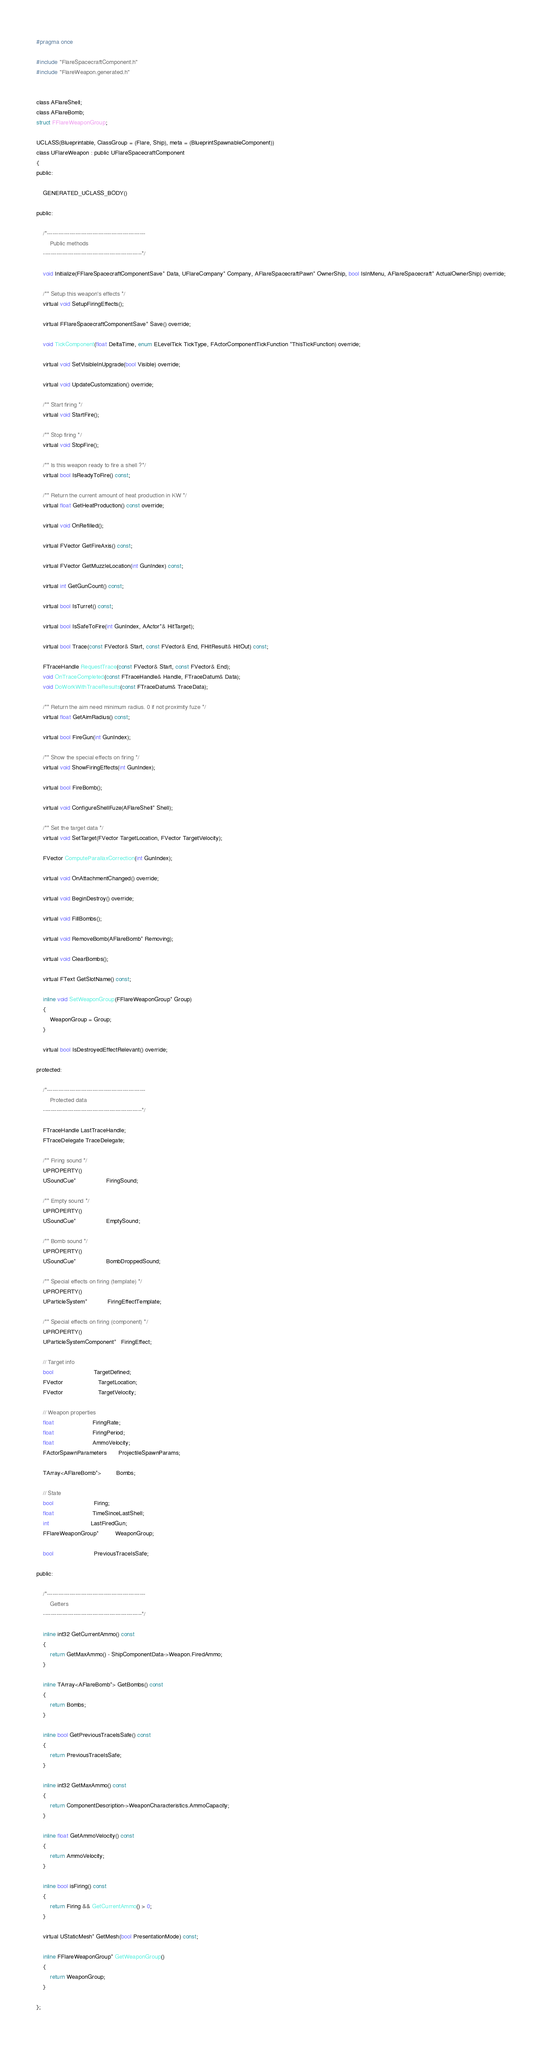Convert code to text. <code><loc_0><loc_0><loc_500><loc_500><_C_>#pragma once

#include "FlareSpacecraftComponent.h"
#include "FlareWeapon.generated.h"


class AFlareShell;
class AFlareBomb;
struct FFlareWeaponGroup;

UCLASS(Blueprintable, ClassGroup = (Flare, Ship), meta = (BlueprintSpawnableComponent))
class UFlareWeapon : public UFlareSpacecraftComponent
{
public:

	GENERATED_UCLASS_BODY()

public:

	/*----------------------------------------------------
		Public methods
	----------------------------------------------------*/

	void Initialize(FFlareSpacecraftComponentSave* Data, UFlareCompany* Company, AFlareSpacecraftPawn* OwnerShip, bool IsInMenu, AFlareSpacecraft* ActualOwnerShip) override;

	/** Setup this weapon's effects */
	virtual void SetupFiringEffects();

	virtual FFlareSpacecraftComponentSave* Save() override;

	void TickComponent(float DeltaTime, enum ELevelTick TickType, FActorComponentTickFunction *ThisTickFunction) override;

	virtual void SetVisibleInUpgrade(bool Visible) override;

	virtual void UpdateCustomization() override;

	/** Start firing */
	virtual void StartFire();

	/** Stop firing */
	virtual void StopFire();

	/** Is this weapon ready to fire a shell ?*/
	virtual bool IsReadyToFire() const;

	/** Return the current amount of heat production in KW */
	virtual float GetHeatProduction() const override;

	virtual void OnRefilled();

	virtual FVector GetFireAxis() const;

	virtual FVector GetMuzzleLocation(int GunIndex) const;

	virtual int GetGunCount() const;

	virtual bool IsTurret() const;

	virtual bool IsSafeToFire(int GunIndex, AActor*& HitTarget);

	virtual bool Trace(const FVector& Start, const FVector& End, FHitResult& HitOut) const;

	FTraceHandle RequestTrace(const FVector& Start, const FVector& End);
	void OnTraceCompleted(const FTraceHandle& Handle, FTraceDatum& Data);
	void DoWorkWithTraceResults(const FTraceDatum& TraceData);

	/** Return the aim need minimum radius. 0 if not proximity fuze */
	virtual float GetAimRadius() const;

	virtual bool FireGun(int GunIndex);

	/** Show the special effects on firing */
	virtual void ShowFiringEffects(int GunIndex);

	virtual bool FireBomb();

	virtual void ConfigureShellFuze(AFlareShell* Shell);

	/** Set the target data */
	virtual void SetTarget(FVector TargetLocation, FVector TargetVelocity);

	FVector ComputeParallaxCorrection(int GunIndex);

	virtual void OnAttachmentChanged() override;

	virtual void BeginDestroy() override;

	virtual void FillBombs();

	virtual void RemoveBomb(AFlareBomb* Removing);

	virtual void ClearBombs();

	virtual FText GetSlotName() const;

	inline void SetWeaponGroup(FFlareWeaponGroup* Group)
	{
		WeaponGroup = Group;
	}

	virtual bool IsDestroyedEffectRelevant() override;

protected:

	/*----------------------------------------------------
		Protected data
	----------------------------------------------------*/

	FTraceHandle LastTraceHandle;
	FTraceDelegate TraceDelegate;

	/** Firing sound */
	UPROPERTY()
	USoundCue*                  FiringSound;

	/** Empty sound */
	UPROPERTY()
	USoundCue*                  EmptySound;

	/** Bomb sound */
	UPROPERTY()
	USoundCue*                  BombDroppedSound;

	/** Special effects on firing (template) */
	UPROPERTY()
	UParticleSystem*            FiringEffectTemplate;

	/** Special effects on firing (component) */
	UPROPERTY()
	UParticleSystemComponent*   FiringEffect;

	// Target info
	bool                        TargetDefined;
	FVector                     TargetLocation;
	FVector                     TargetVelocity;

	// Weapon properties
	float                       FiringRate;
	float                       FiringPeriod;
	float                       AmmoVelocity;
	FActorSpawnParameters       ProjectileSpawnParams;

	TArray<AFlareBomb*>         Bombs;

	// State
	bool                        Firing;
	float                       TimeSinceLastShell;
	int                         LastFiredGun;
	FFlareWeaponGroup*          WeaponGroup;

	bool						PreviousTraceIsSafe;

public:

	/*----------------------------------------------------
		Getters
	----------------------------------------------------*/

	inline int32 GetCurrentAmmo() const
	{
		return GetMaxAmmo() - ShipComponentData->Weapon.FiredAmmo;
	}

	inline TArray<AFlareBomb*> GetBombs() const
	{
		return Bombs;
	}

	inline bool GetPreviousTraceIsSafe() const
	{
		return PreviousTraceIsSafe;
	}

	inline int32 GetMaxAmmo() const
	{
		return ComponentDescription->WeaponCharacteristics.AmmoCapacity;
	}

	inline float GetAmmoVelocity() const
	{
		return AmmoVelocity;
	}

	inline bool isFiring() const
	{
		return Firing && GetCurrentAmmo() > 0;
	}

	virtual UStaticMesh* GetMesh(bool PresentationMode) const;

	inline FFlareWeaponGroup* GetWeaponGroup()
	{
		return WeaponGroup;
	}

};
</code> 